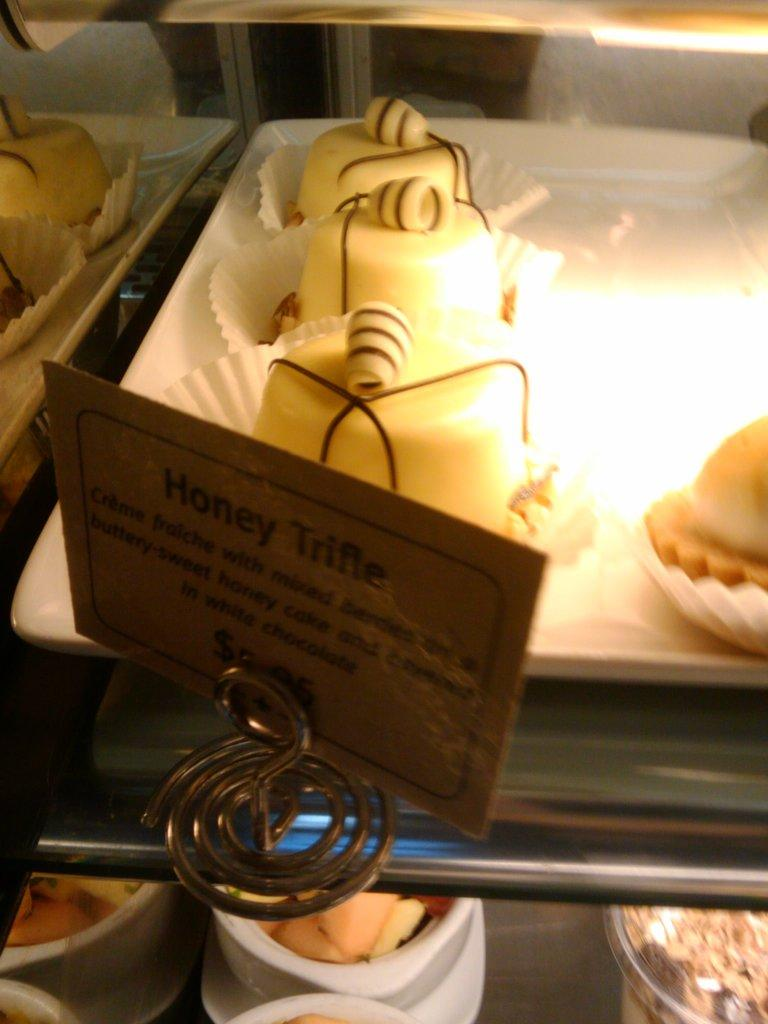What type of food can be seen in the image? There are cakes in the image. How are the cakes arranged or displayed? The cakes are in trays. What material are the trays made of? The trays are made of glass. Is there any text or writing visible in the image? Yes, there is a board with text in the image. What type of bird can be seen flying in the image? There are no birds visible in the image; it features cakes in trays made of glass. What type of rhythm is being played in the background of the image? There is no music or rhythm present in the image; it only shows cakes in trays and a board with text. 